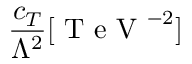Convert formula to latex. <formula><loc_0><loc_0><loc_500><loc_500>\frac { c _ { T } } { \Lambda ^ { 2 } } [ T e V ^ { - 2 } ]</formula> 